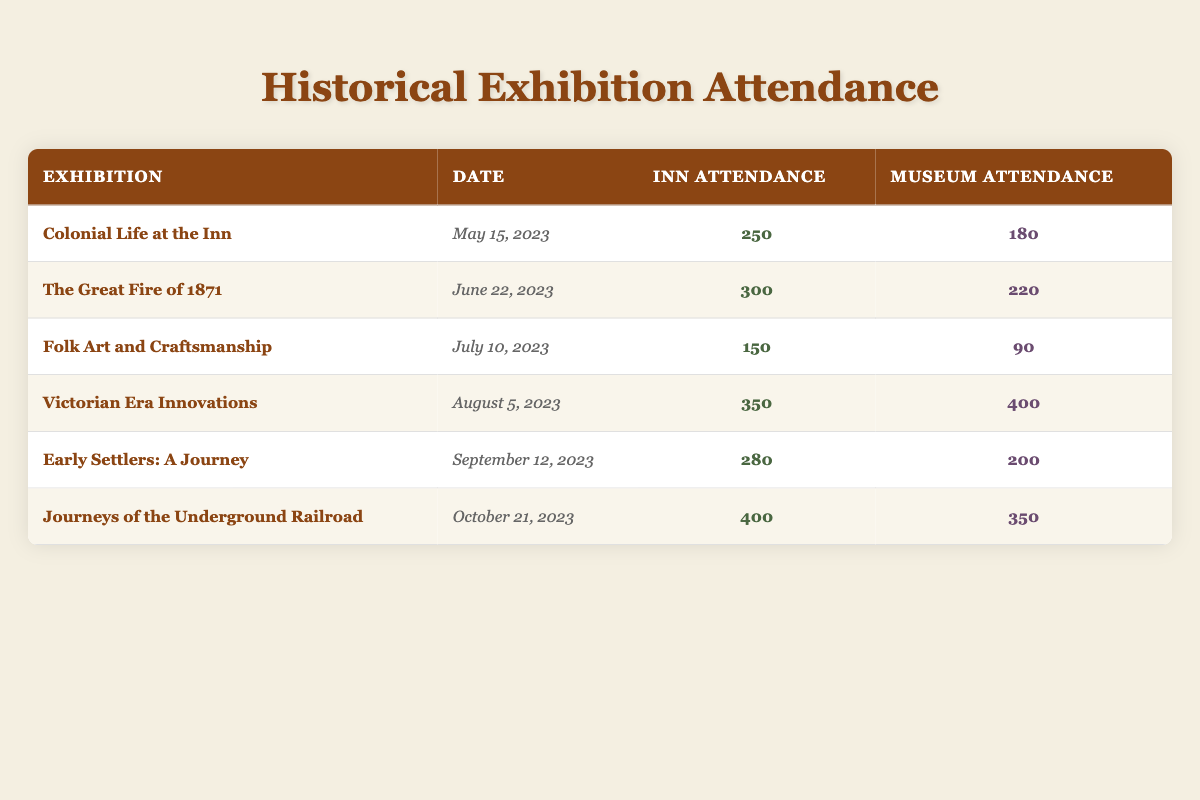What was the attendance for the exhibition "Victorian Era Innovations"? The table shows that the inn attendance for "Victorian Era Innovations" was 350, and museum attendance was 400.
Answer: 350 Which exhibition had the highest attendance at the inn? By comparing the inn attendance figures, "Journeys of the Underground Railroad" has the highest attendance with 400.
Answer: 400 What is the total attendance for both the inn and the museum for the "The Great Fire of 1871"? The inn attendance for "The Great Fire of 1871" is 300 and museum attendance is 220. Adding those two figures gives us 300 + 220 = 520.
Answer: 520 Did the "Early Settlers: A Journey" exhibition attract more people to the inn than "Folk Art and Craftsmanship"? The inn attendance for "Early Settlers: A Journey" is 280, while "Folk Art and Craftsmanship" had 150. Since 280 is greater than 150, the statement is true.
Answer: Yes What is the average attendance at the museum across all exhibitions listed? To find the average museum attendance, sum all museum attendance figures: 180 + 220 + 90 + 400 + 200 + 350 = 1530. There are 6 exhibitions, so the average is 1530 / 6 = 255.
Answer: 255 Which exhibition had the largest difference in attendance between the inn and museum? The attendance difference for each exhibition needs to be calculated. The largest difference is for "Victorian Era Innovations," with the difference being 400 (museum) - 350 (inn) = 50. Checking others shows they all have smaller differences.
Answer: 50 